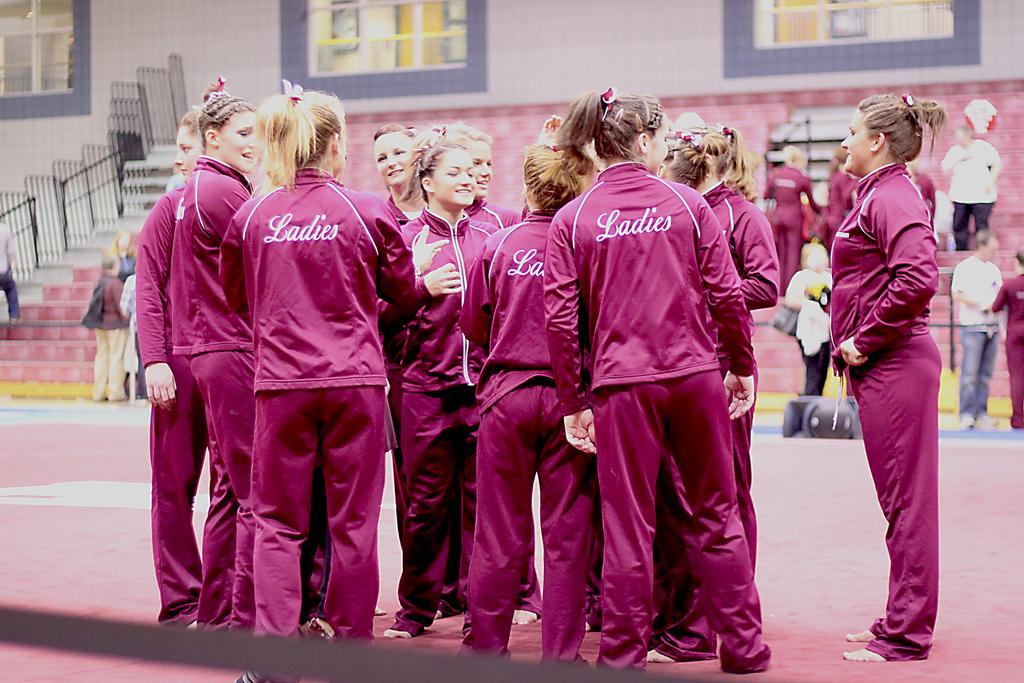<image>
Give a short and clear explanation of the subsequent image. Women in uniforms that say Ladies on the back are gathered in a huddle. 